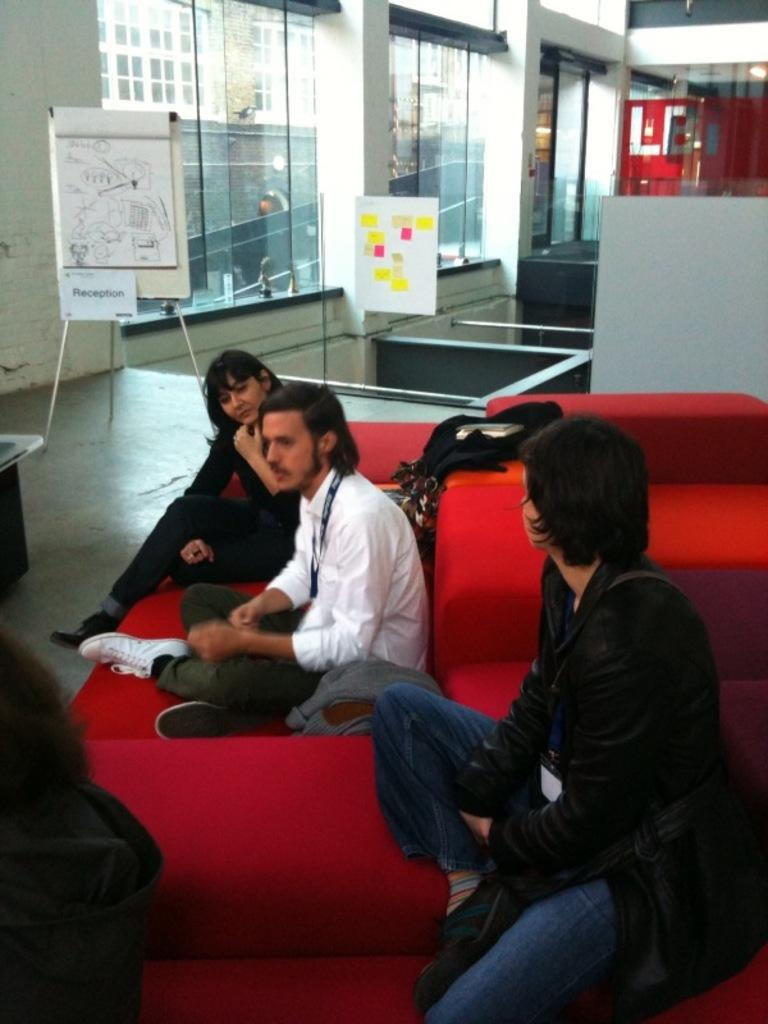What can be seen in the foreground of the image? There are people sitting in the foreground of the image. What type of architectural feature is visible in the background of the image? There are glass windows and buildings in the background of the image. What is the board used for in the image? The board in the background of the image is likely used for displaying information or announcements. What other objects can be seen in the background of the image? There are other objects in the background of the image, but their specific nature is not mentioned in the provided facts. How many committee members are visible in the image? There is no mention of a committee or committee members in the provided facts, so it cannot be determined from the image. What type of sink is present in the image? There is no sink present in the image; the facts mention glass windows, buildings, a board, and other objects in the background, but not a sink. 